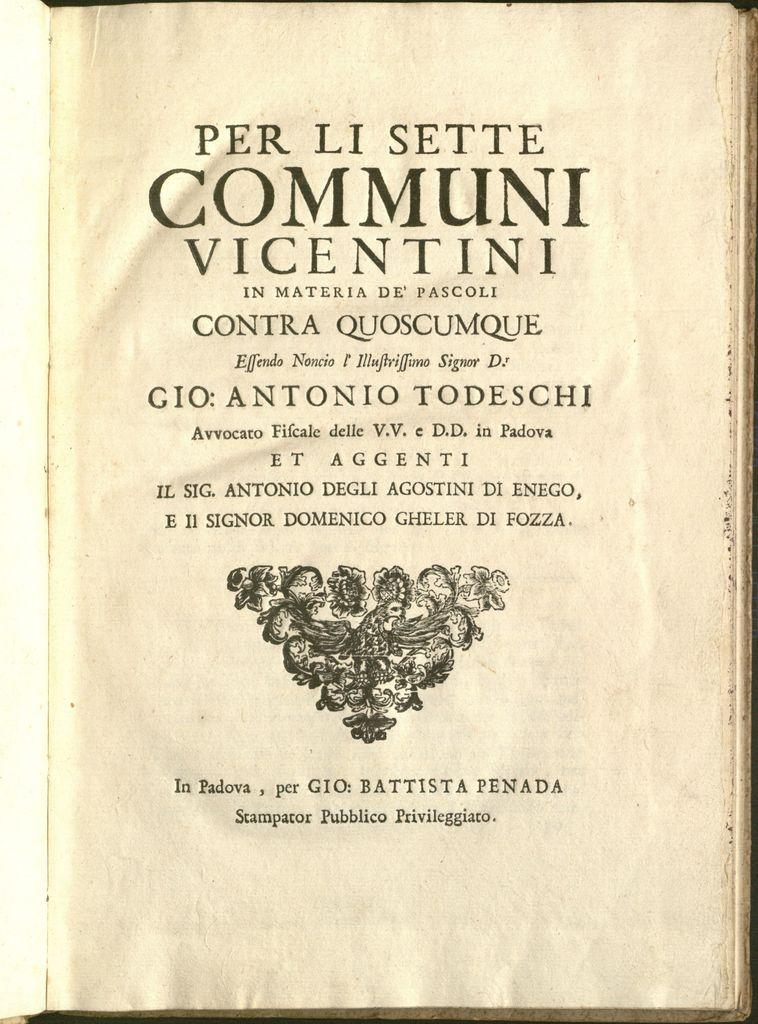<image>
Write a terse but informative summary of the picture. A book title with graphics is written in a foreign language. 